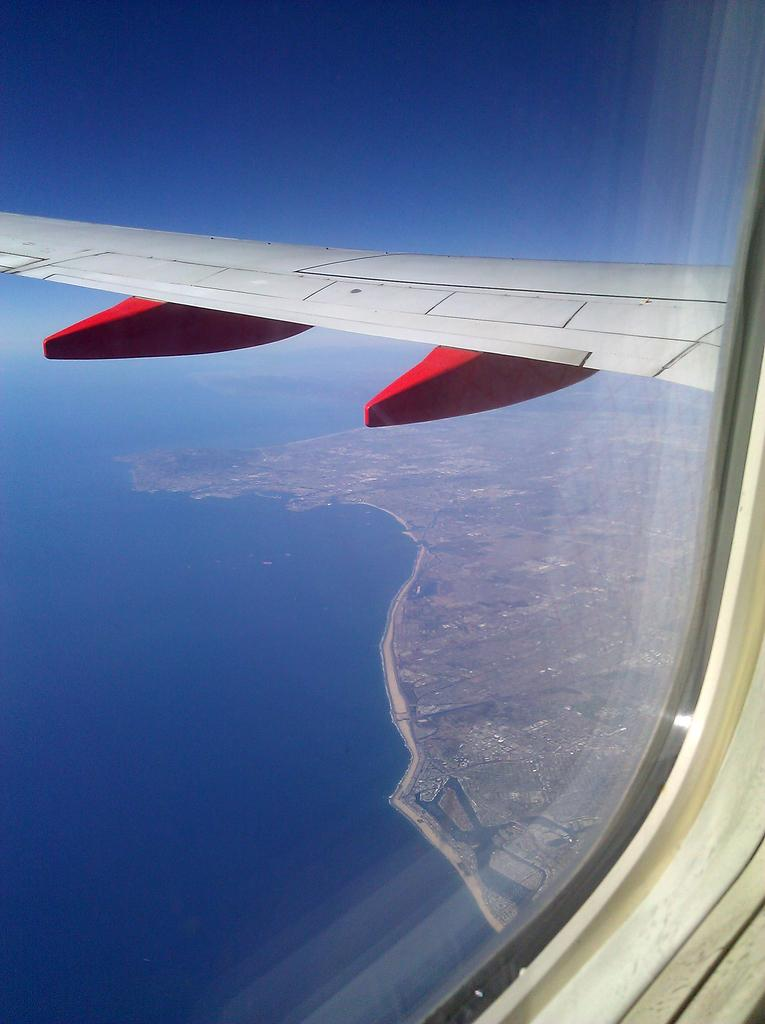What is the main subject of the image? The main subject of the image is an airplane wing. What can be seen in the background of the image? There is water visible in the image. What type of shirt is being worn by the person playing with the wire in the image? There is no person wearing a shirt or playing with a wire in the image, as it only features an airplane wing and water. 